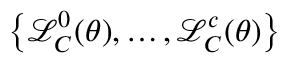Convert formula to latex. <formula><loc_0><loc_0><loc_500><loc_500>\left \{ \mathcal { L } _ { C } ^ { 0 } ( \theta ) , \dots , \mathcal { L } _ { C } ^ { c } ( \theta ) \right \}</formula> 